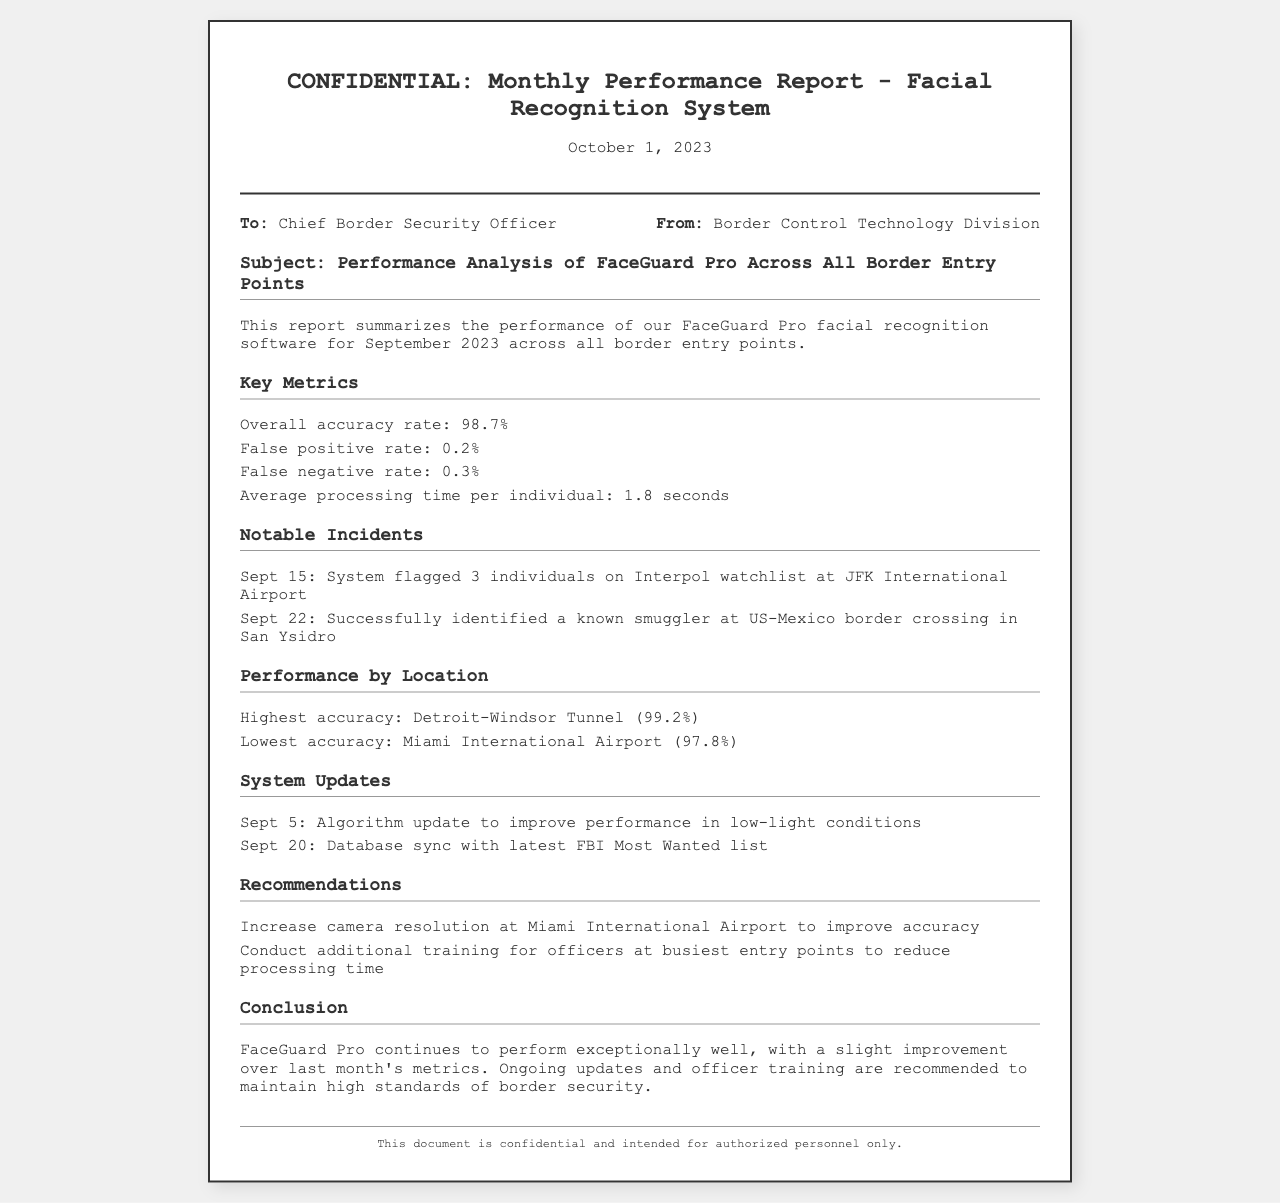What is the overall accuracy rate? The overall accuracy rate is a key metric outlined in the report indicating how effectively the system performs, which is 98.7%.
Answer: 98.7% What is the false positive rate? The false positive rate is mentioned as part of the key metrics in the report, which is 0.2%.
Answer: 0.2% What incident occurred on September 15? The report lists notable incidents, specifying one that occurred on September 15 involving flagging individuals on the Interpol watchlist.
Answer: System flagged 3 individuals on Interpol watchlist at JFK International Airport What is the highest accuracy rate by location? The report includes performance by location, where the highest accuracy is noted, which is 99.2%.
Answer: Detroit-Windsor Tunnel (99.2%) What recommendation is made for Miami International Airport? The recommendations section provides insights on improvements, particularly noting the camera resolution issue at Miami International Airport.
Answer: Increase camera resolution at Miami International Airport to improve accuracy What was updated on September 5? The system updates list an algorithm change made on September 5 to enhance certain conditions, specifically low-light performance.
Answer: Algorithm update to improve performance in low-light conditions How many seconds is the average processing time per individual? The report states the average processing time per individual as a key metric, specifically mentioned in seconds, which is 1.8 seconds.
Answer: 1.8 seconds Who is the report intended for? The report mentions the intended recipient in the meta-info section, which is the Chief Border Security Officer.
Answer: Chief Border Security Officer 